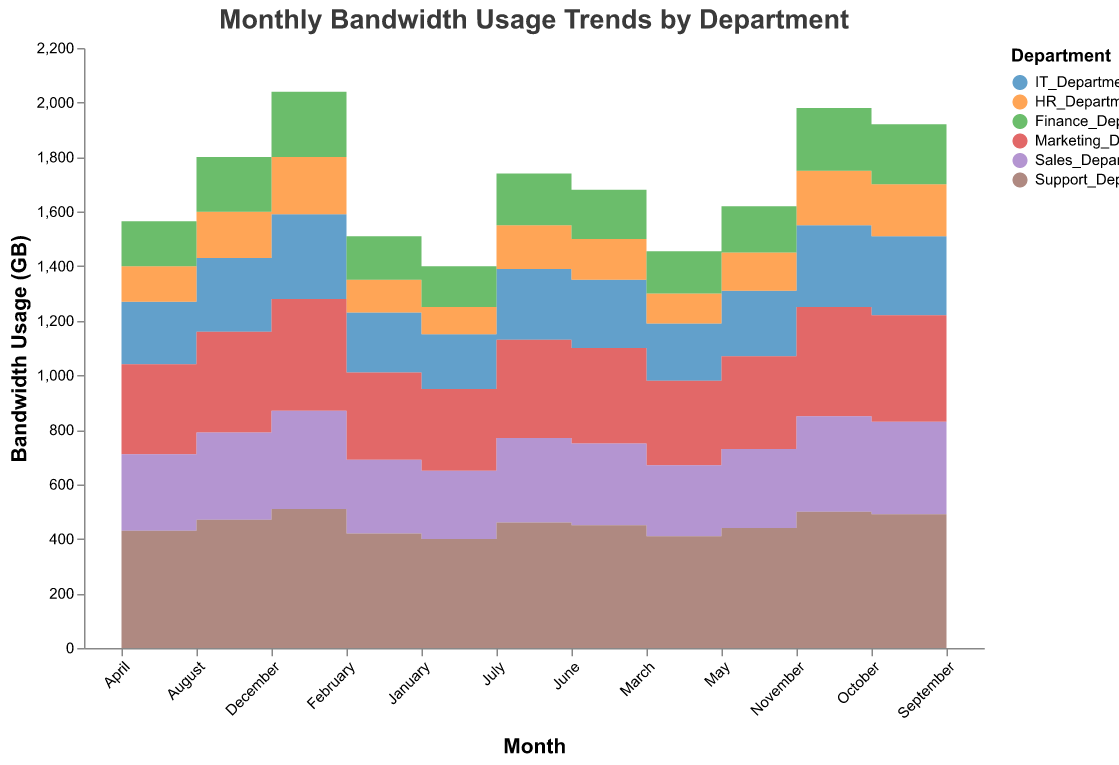What's the title of the chart? The title is usually positioned prominently at the top center of the chart; in this case, it reads "Monthly Bandwidth Usage Trends by Department."
Answer: Monthly Bandwidth Usage Trends by Department Which department has the highest bandwidth usage in December? To find this, look for the highest value in the December month column. The Support Department shows the highest usage at 510 GB.
Answer: Support_Department What's the pattern of bandwidth usage in the HR Department over the year? Observing the area corresponding to the HR Department, we see a steady and consistent increase in bandwidth usage from January (100 GB) to December (210 GB).
Answer: Steady increase Which months saw a significant increase in IT Department bandwidth usage, and by how much? Notable increases occur in April (230 GB from 210 GB in March) and November (300 GB from 290 GB in October). In April, the increase is 230 - 210 = 20 GB. In November, it's 300 - 290 = 10 GB.
Answer: April (20 GB), November (10 GB) Compare the bandwidth trends between Marketing Department and Sales Department across the year. Both departments exhibit a linear increase in bandwidth usage over the year. However, Marketing starts and ends with higher values (300 GB in January to 410 GB in December) compared to Sales (250 GB in January to 360 GB in December).
Answer: Marketing trends are higher throughout the year Which department(s) have consistent month-over-month growth in bandwidth usage? By examining the plotted areas, the IT Department, HR Department, Finance Department, Marketing Department, Sales Department, and Support Department all show consistent growth each month without any dips.
Answer: All departments What is the total combined bandwidth usage of all departments in July? Sum the values for each department in July: IT (260 GB), HR (160 GB), Finance (190 GB), Marketing (360 GB), Sales (310 GB), and Support (460 GB). The total is 260 + 160 + 190 + 360 + 310 + 460 = 1740 GB.
Answer: 1740 GB Did any department's bandwidth usage decline in any month? The trend lines for each department display stepwise increases without any drops, indicating that no department experienced a decline in bandwidth usage in any month.
Answer: No What is the average monthly bandwidth usage for the Support Department? Calculate the average: (400 + 420 + 410 + 430 + 440 + 450 + 460 + 470 + 480 + 490 + 500 + 510) / 12 = 4560 / 12 = 380 GB.
Answer: 380 GB 